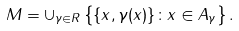Convert formula to latex. <formula><loc_0><loc_0><loc_500><loc_500>M = \cup _ { \gamma \in R } \left \{ \{ x , \gamma ( x ) \} \colon x \in A _ { \gamma } \right \} .</formula> 